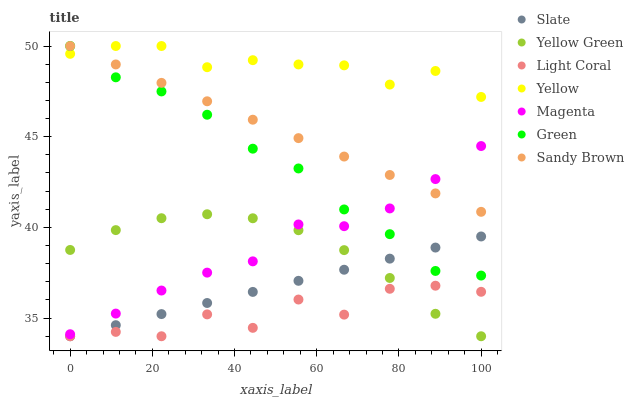Does Light Coral have the minimum area under the curve?
Answer yes or no. Yes. Does Yellow have the maximum area under the curve?
Answer yes or no. Yes. Does Slate have the minimum area under the curve?
Answer yes or no. No. Does Slate have the maximum area under the curve?
Answer yes or no. No. Is Slate the smoothest?
Answer yes or no. Yes. Is Light Coral the roughest?
Answer yes or no. Yes. Is Yellow the smoothest?
Answer yes or no. No. Is Yellow the roughest?
Answer yes or no. No. Does Yellow Green have the lowest value?
Answer yes or no. Yes. Does Yellow have the lowest value?
Answer yes or no. No. Does Sandy Brown have the highest value?
Answer yes or no. Yes. Does Slate have the highest value?
Answer yes or no. No. Is Slate less than Yellow?
Answer yes or no. Yes. Is Sandy Brown greater than Slate?
Answer yes or no. Yes. Does Yellow intersect Sandy Brown?
Answer yes or no. Yes. Is Yellow less than Sandy Brown?
Answer yes or no. No. Is Yellow greater than Sandy Brown?
Answer yes or no. No. Does Slate intersect Yellow?
Answer yes or no. No. 